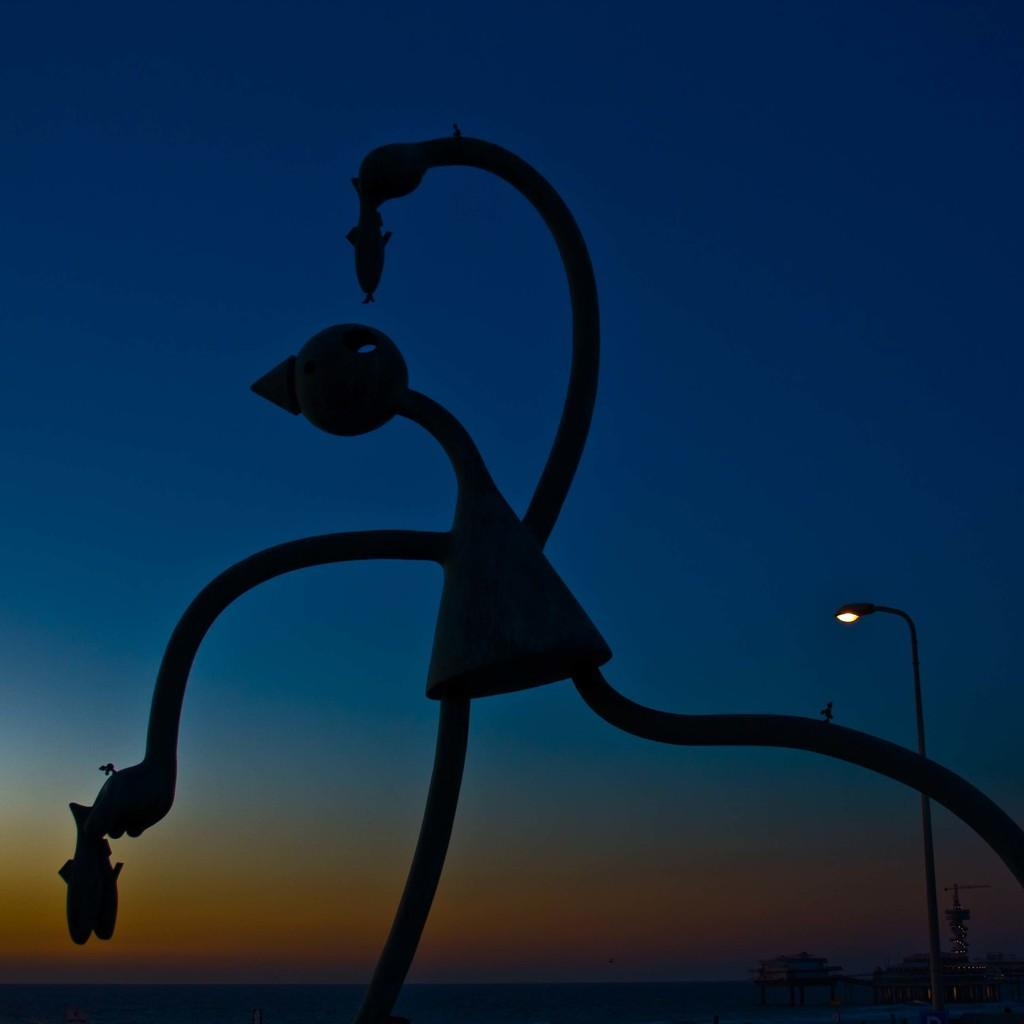What can be seen in the background of the image? The sky is visible in the image. What is the main subject in the image? There is a metallic craft in the image. Are there any other objects or structures in the image? Yes, there is a street light in the image. What type of hands can be seen holding the metallic craft in the image? There are no hands visible in the image, and the metallic craft is not being held by any hands. 